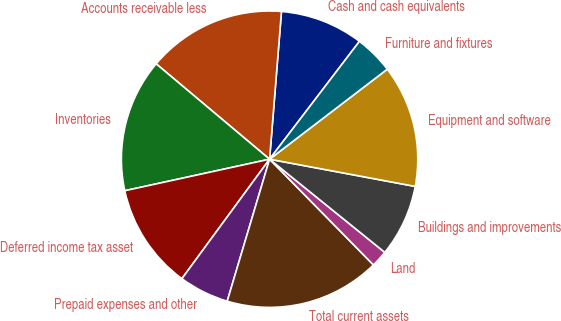<chart> <loc_0><loc_0><loc_500><loc_500><pie_chart><fcel>Cash and cash equivalents<fcel>Accounts receivable less<fcel>Inventories<fcel>Deferred income tax asset<fcel>Prepaid expenses and other<fcel>Total current assets<fcel>Land<fcel>Buildings and improvements<fcel>Equipment and software<fcel>Furniture and fixtures<nl><fcel>9.09%<fcel>15.15%<fcel>14.54%<fcel>11.51%<fcel>5.46%<fcel>16.97%<fcel>1.82%<fcel>7.88%<fcel>13.33%<fcel>4.24%<nl></chart> 